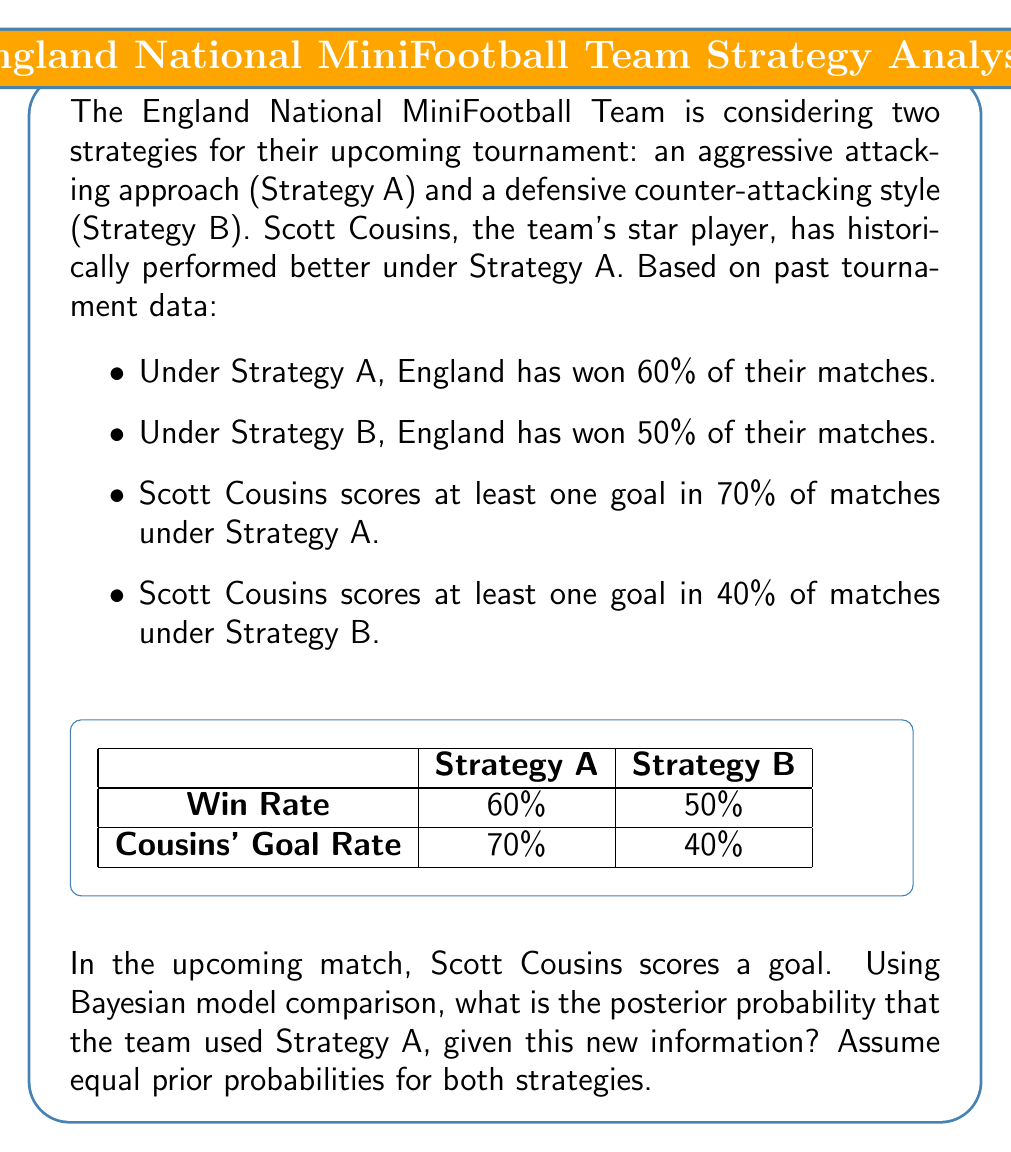Can you solve this math problem? Let's approach this step-by-step using Bayes' theorem and model comparison:

1) Define our events:
   A: Strategy A was used
   B: Strategy B was used
   G: Scott Cousins scored a goal

2) We're looking for P(A|G), the probability of Strategy A given that Cousins scored.

3) Bayes' theorem states:

   $$P(A|G) = \frac{P(G|A) \cdot P(A)}{P(G)}$$

4) We know:
   P(G|A) = 0.7 (Cousins scores 70% of the time under Strategy A)
   P(G|B) = 0.4 (Cousins scores 40% of the time under Strategy B)
   P(A) = P(B) = 0.5 (equal prior probabilities)

5) We can calculate P(G) using the law of total probability:
   
   $$P(G) = P(G|A) \cdot P(A) + P(G|B) \cdot P(B)$$
   $$P(G) = 0.7 \cdot 0.5 + 0.4 \cdot 0.5 = 0.35 + 0.2 = 0.55$$

6) Now we can apply Bayes' theorem:

   $$P(A|G) = \frac{0.7 \cdot 0.5}{0.55} = \frac{0.35}{0.55} = \frac{7}{11} \approx 0.6364$$

Therefore, given that Scott Cousins scored a goal, the posterior probability that the team used Strategy A is approximately 63.64%.
Answer: $\frac{7}{11}$ or approximately 0.6364 (63.64%) 